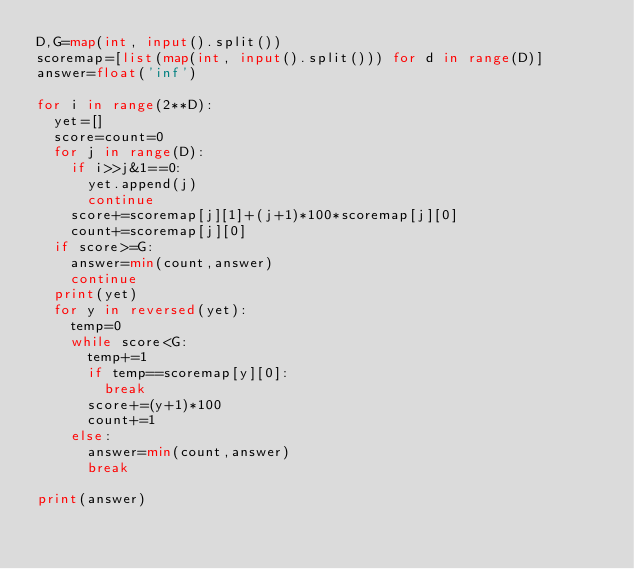<code> <loc_0><loc_0><loc_500><loc_500><_Python_>D,G=map(int, input().split())
scoremap=[list(map(int, input().split())) for d in range(D)]
answer=float('inf')

for i in range(2**D):
  yet=[]
  score=count=0
  for j in range(D):
    if i>>j&1==0:
      yet.append(j)
      continue
    score+=scoremap[j][1]+(j+1)*100*scoremap[j][0]
    count+=scoremap[j][0]
  if score>=G:
    answer=min(count,answer)
    continue
  print(yet)
  for y in reversed(yet):
    temp=0
    while score<G:
      temp+=1
      if temp==scoremap[y][0]:
        break
      score+=(y+1)*100
      count+=1
    else:
      answer=min(count,answer)
      break

print(answer)
    </code> 